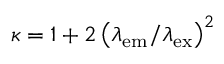<formula> <loc_0><loc_0><loc_500><loc_500>\kappa = 1 + 2 \left ( \lambda _ { e m } / \lambda _ { e x } \right ) ^ { 2 }</formula> 